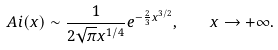<formula> <loc_0><loc_0><loc_500><loc_500>\ A i ( x ) \sim \frac { 1 } { 2 \sqrt { \pi } x ^ { 1 / 4 } } e ^ { - \frac { 2 } { 3 } x ^ { 3 / 2 } } , \quad x \to + \infty .</formula> 